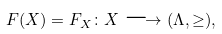Convert formula to latex. <formula><loc_0><loc_0><loc_500><loc_500>F ( X ) = F _ { X } \colon X \longrightarrow ( \Lambda , \geq ) ,</formula> 